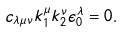Convert formula to latex. <formula><loc_0><loc_0><loc_500><loc_500>c _ { \lambda \mu \nu } k _ { 1 } ^ { \mu } k _ { 2 } ^ { \nu } \epsilon _ { 0 } ^ { \lambda } = 0 .</formula> 